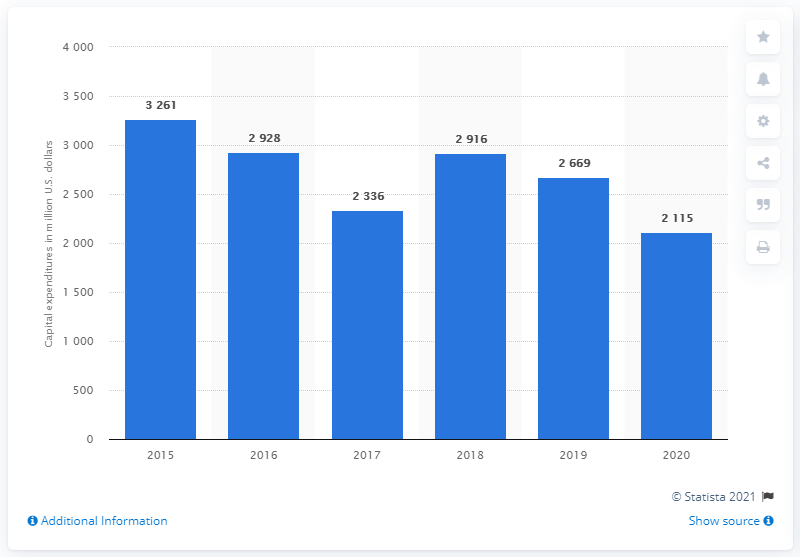Specify some key components in this picture. Caterpillar spent approximately $2,115 million in 2020. 